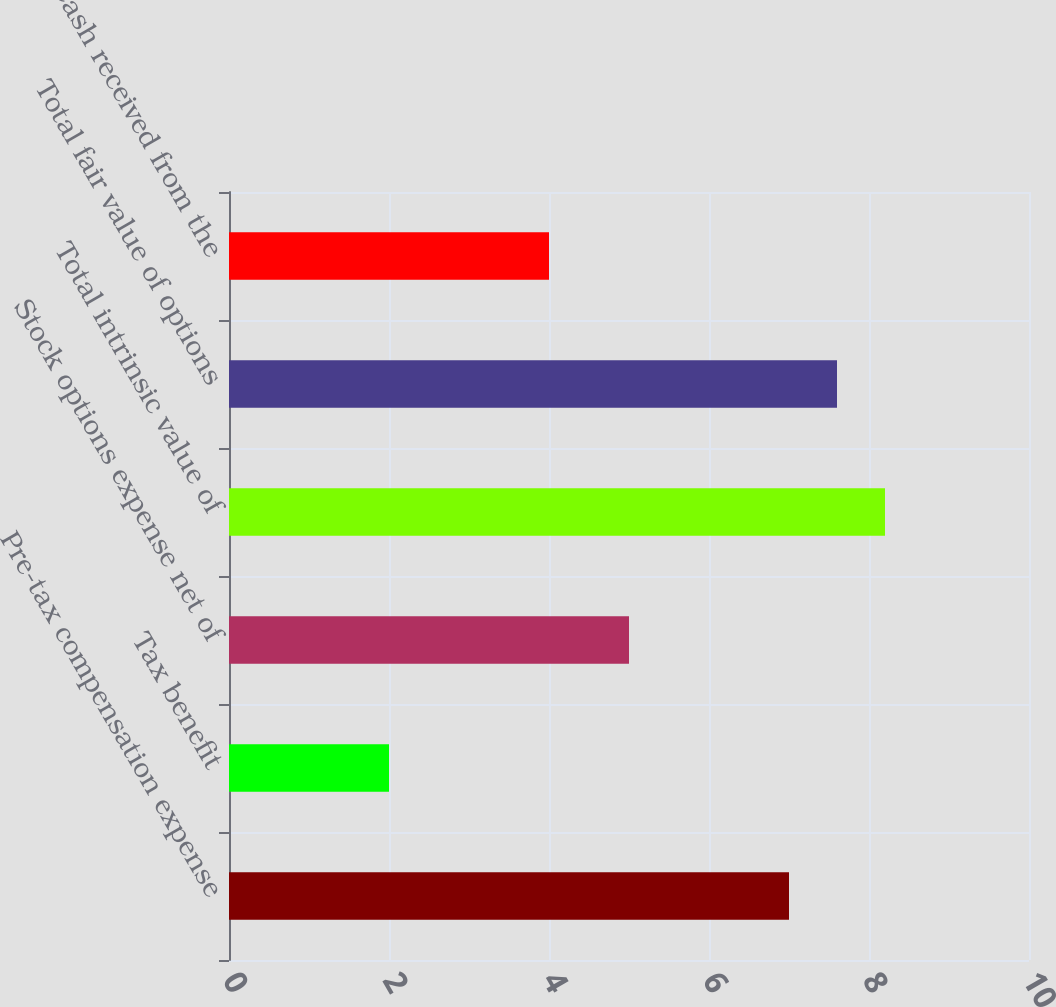<chart> <loc_0><loc_0><loc_500><loc_500><bar_chart><fcel>Pre-tax compensation expense<fcel>Tax benefit<fcel>Stock options expense net of<fcel>Total intrinsic value of<fcel>Total fair value of options<fcel>Cash received from the<nl><fcel>7<fcel>2<fcel>5<fcel>8.2<fcel>7.6<fcel>4<nl></chart> 